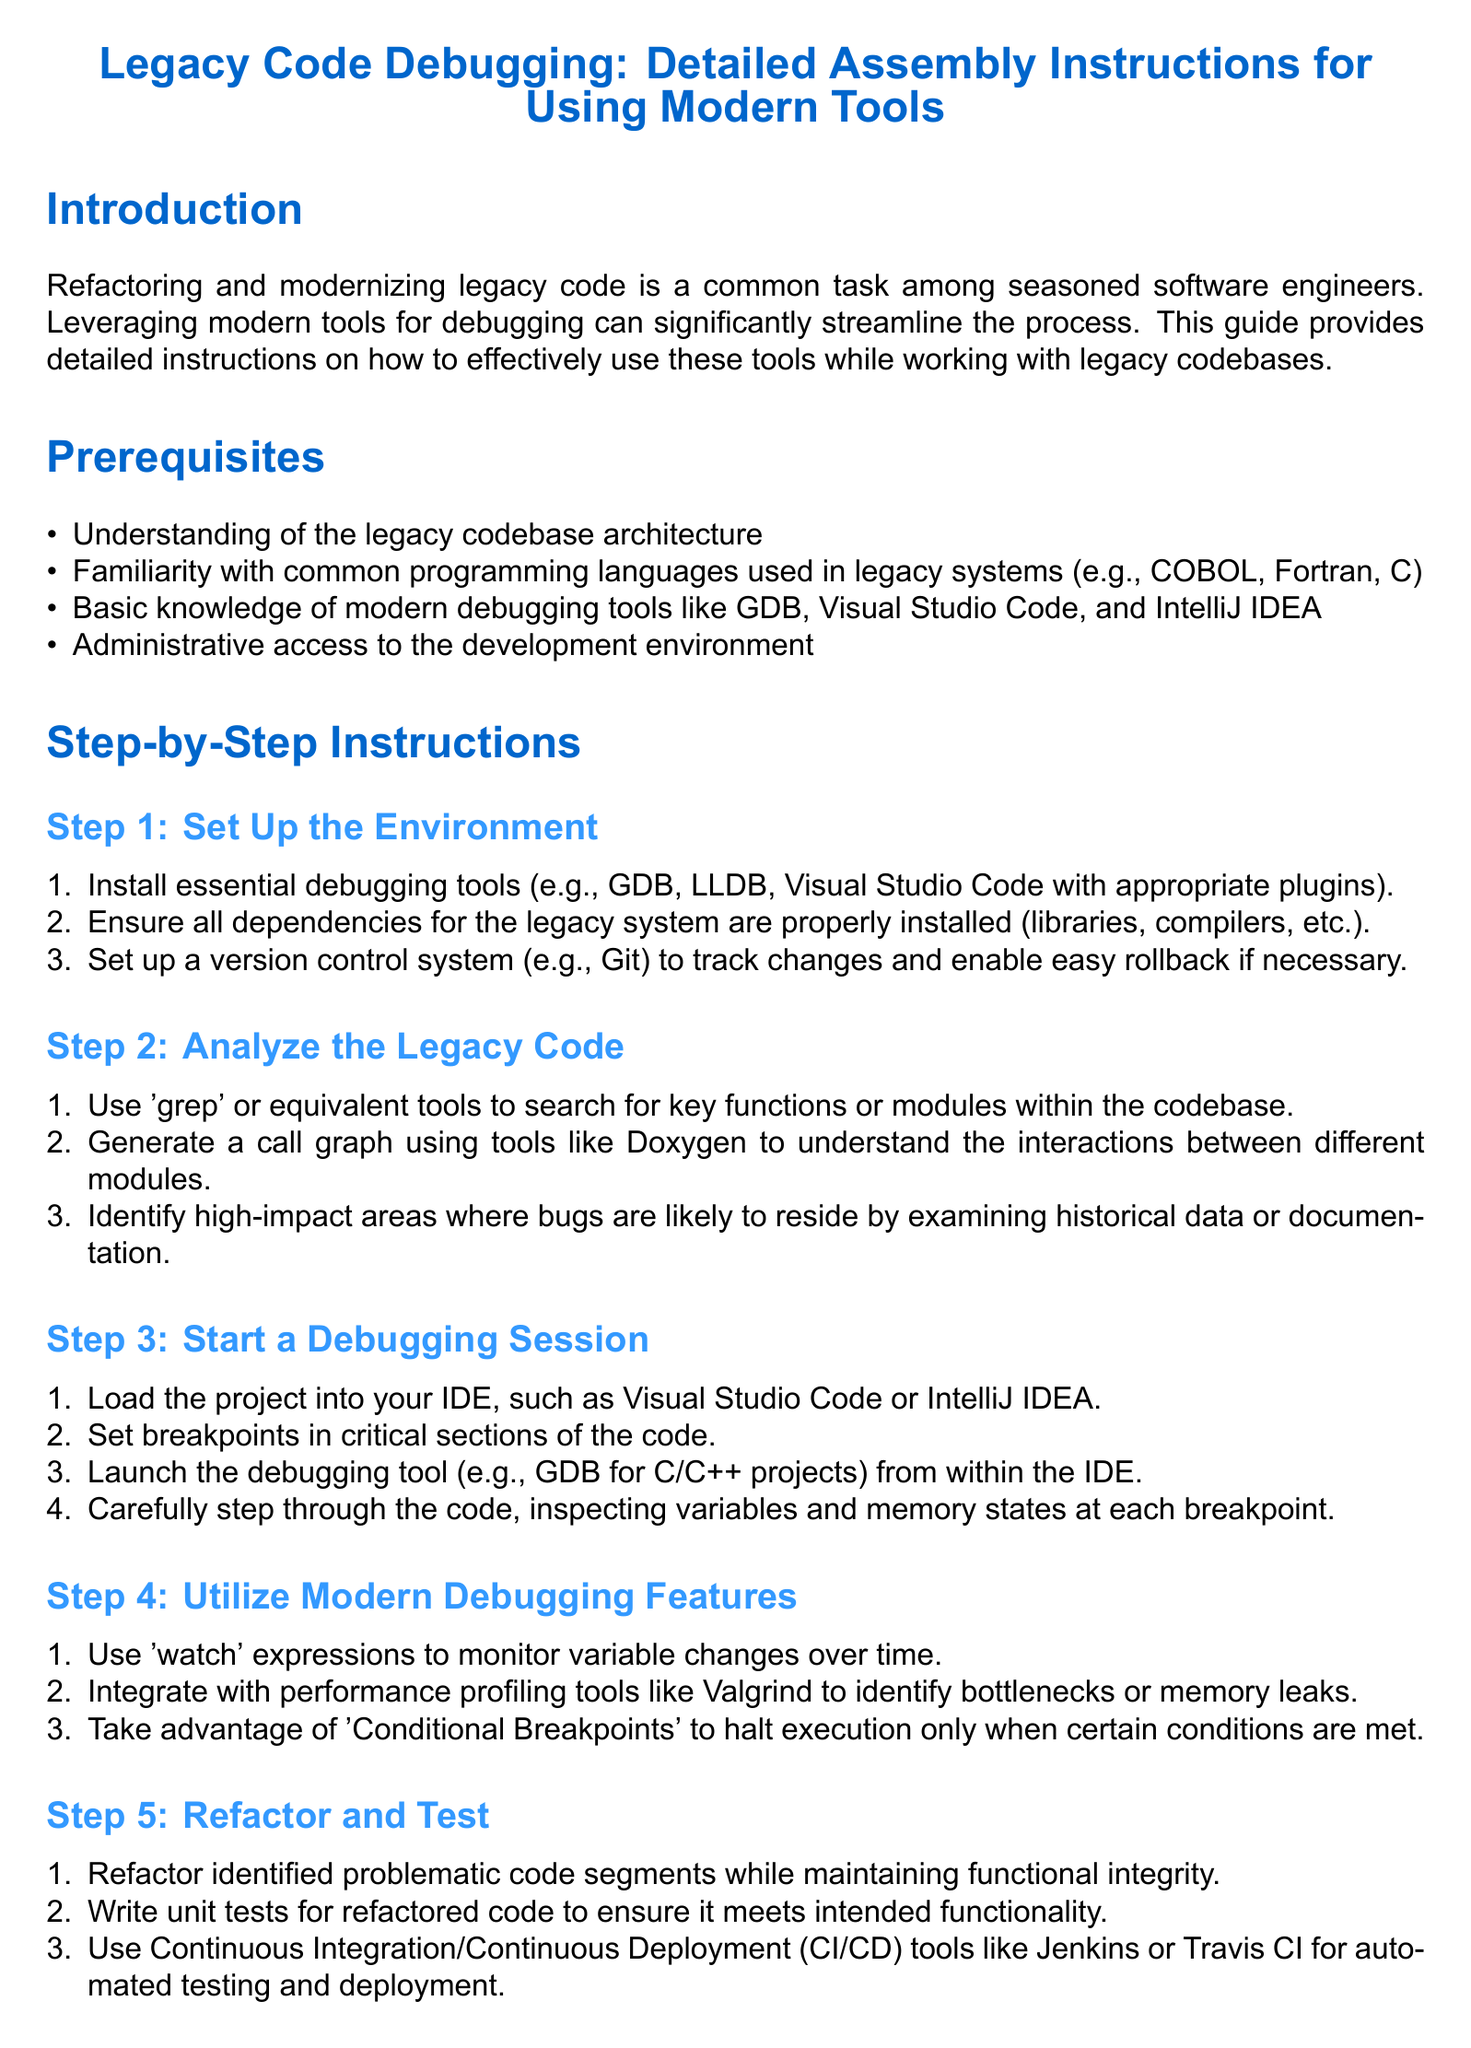What is the title of the document? The title of the document is mentioned in the center at the top, which outlines its focus on legacy code debugging and modern tools.
Answer: Legacy Code Debugging: Detailed Assembly Instructions for Using Modern Tools What is the first step in the instructions? The first step is detailed in the section titled "Step 1: Set Up the Environment," which outlines initial preparations.
Answer: Set Up the Environment Which debugging tools are suggested to install? The document lists essential debugging tools, specifically mentioning GDB and Visual Studio Code among others.
Answer: GDB What is one method to analyze legacy code? The methods to analyze the legacy code include using tools like 'grep' to search for functions within the codebase.
Answer: grep What should be monitored over time during debugging? The instructions highlight that 'watch' expressions should be used to observe the changes in specific variables throughout the debugging process.
Answer: variable changes How many prerequisites are listed? The "Prerequisites" section enumerates the required prior knowledge and skills before engaging with the instructions, totaling five items.
Answer: Four What is the last step mentioned in the instructions? The instructions culminate in the section titled "Step 5: Refactor and Test," which involves making changes and verifying their correctness.
Answer: Refactor and Test What is recommended for automated testing and deployment? The document suggests using CI/CD tools to facilitate automation in testing and deployment processes.
Answer: CI/CD tools Which book is mentioned as a reference for debugging? The references section includes a book specifically focused on debugging methodologies, identified by the author's names.
Answer: The Art of Debugging with GDB, DDD, and Eclipse 